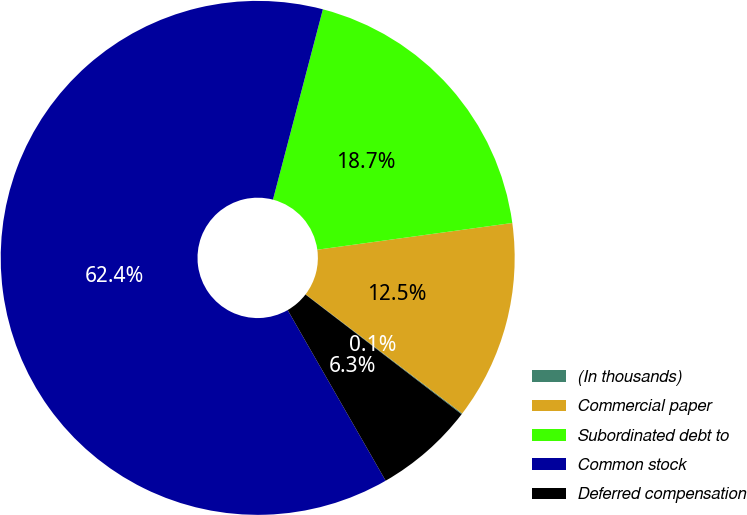Convert chart. <chart><loc_0><loc_0><loc_500><loc_500><pie_chart><fcel>(In thousands)<fcel>Commercial paper<fcel>Subordinated debt to<fcel>Common stock<fcel>Deferred compensation<nl><fcel>0.06%<fcel>12.52%<fcel>18.75%<fcel>62.38%<fcel>6.29%<nl></chart> 